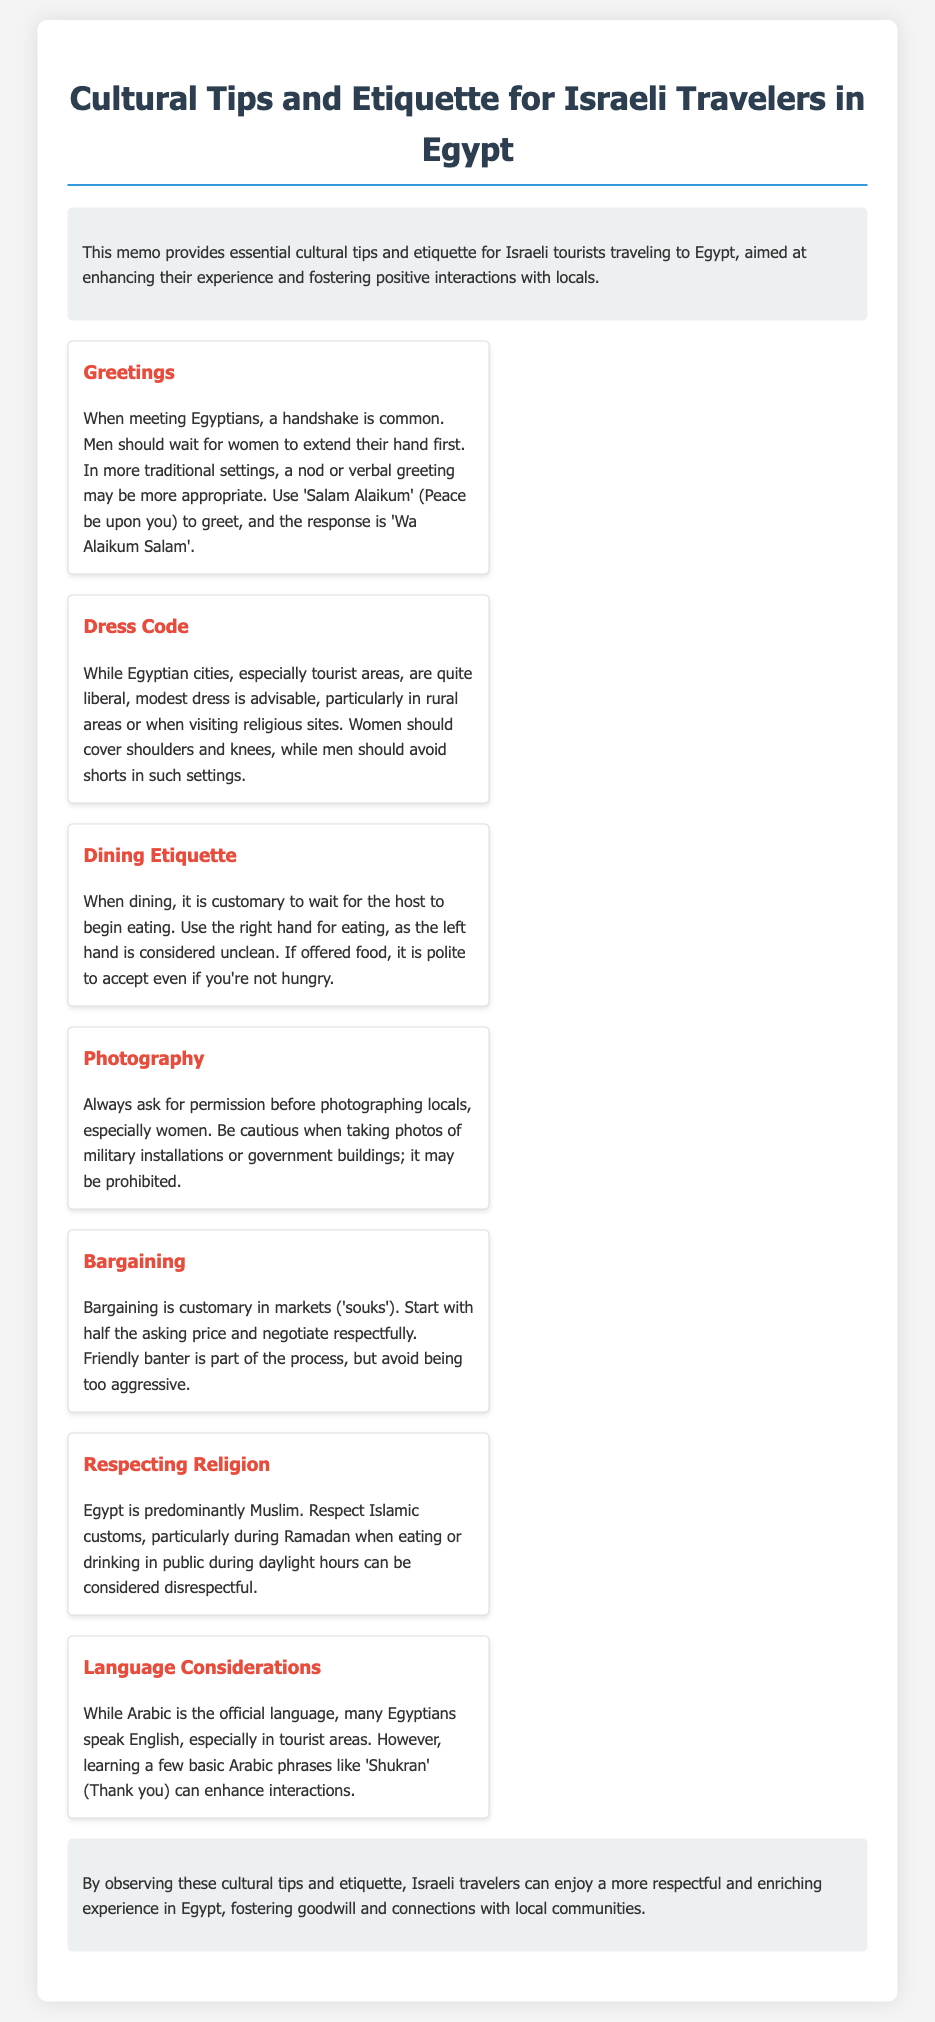What is the title of the memo? The title is a clear indication of the content and main topic of the document, which is "Cultural Tips and Etiquette for Israeli Travelers in Egypt."
Answer: Cultural Tips and Etiquette for Israeli Travelers in Egypt What is a common greeting in Egypt? The memo provides specific cultural practices, including greetings; "Salam Alaikum" is mentioned as a common greeting.
Answer: Salam Alaikum What should women avoid wearing in rural areas? The document specifies a dress code, indicating what women should avoid in rural areas to adhere to cultural norms.
Answer: Shorts When dining, whose turn is it to start eating? The dining etiquette section explains the customary practice of waiting for the host to start.
Answer: Host What hand should be used for eating? The document clearly states the etiquette regarding hand usage while eating in Egypt.
Answer: Right hand How should tourists respond to being offered food? The memo describes the polite response to food offerings, which reflects cultural norms in Egypt.
Answer: Accept What is considered disrespectful during Ramadan? The memo highlights specific behaviors to avoid during Ramadan, focusing on local customs regarding food and drink.
Answer: Eating or drinking in public What should tourists do before taking photos of locals? The photography etiquette provided in the document indicates the proper way to take photos of people.
Answer: Ask for permission 